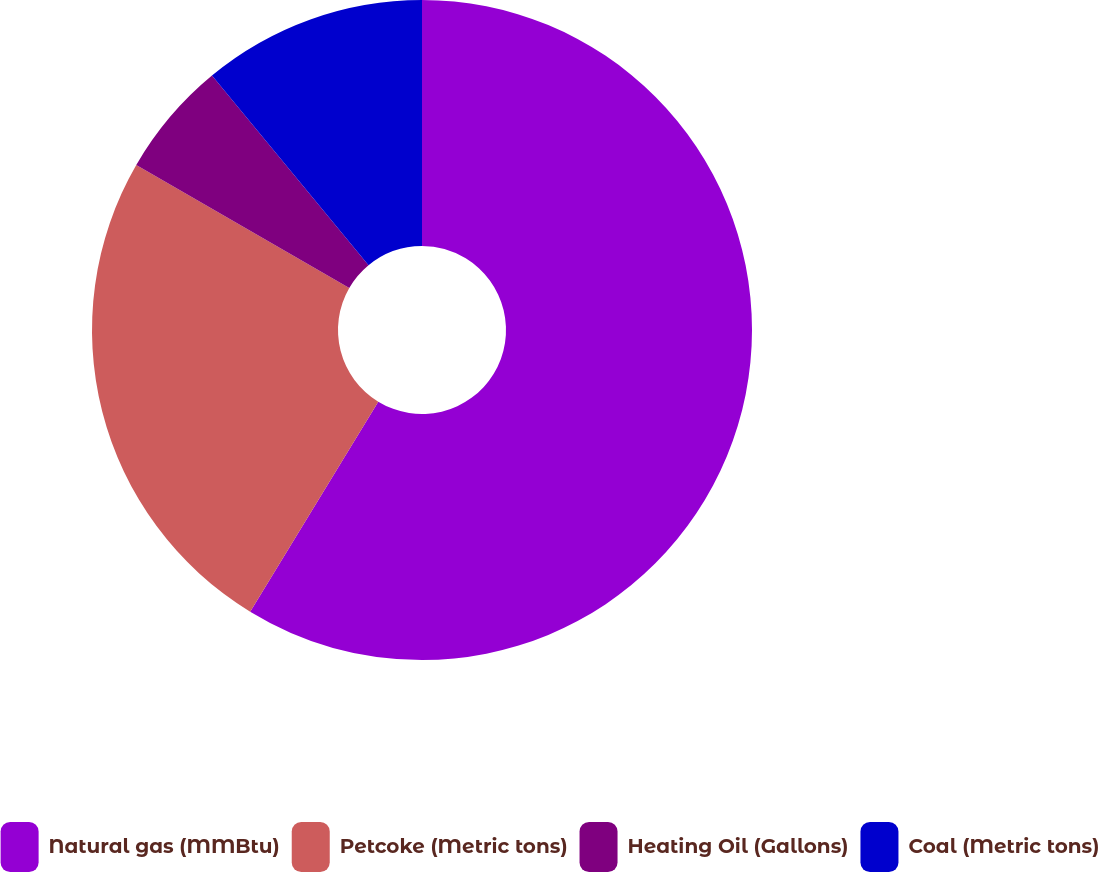<chart> <loc_0><loc_0><loc_500><loc_500><pie_chart><fcel>Natural gas (MMBtu)<fcel>Petcoke (Metric tons)<fcel>Heating Oil (Gallons)<fcel>Coal (Metric tons)<nl><fcel>58.71%<fcel>24.62%<fcel>5.68%<fcel>10.98%<nl></chart> 